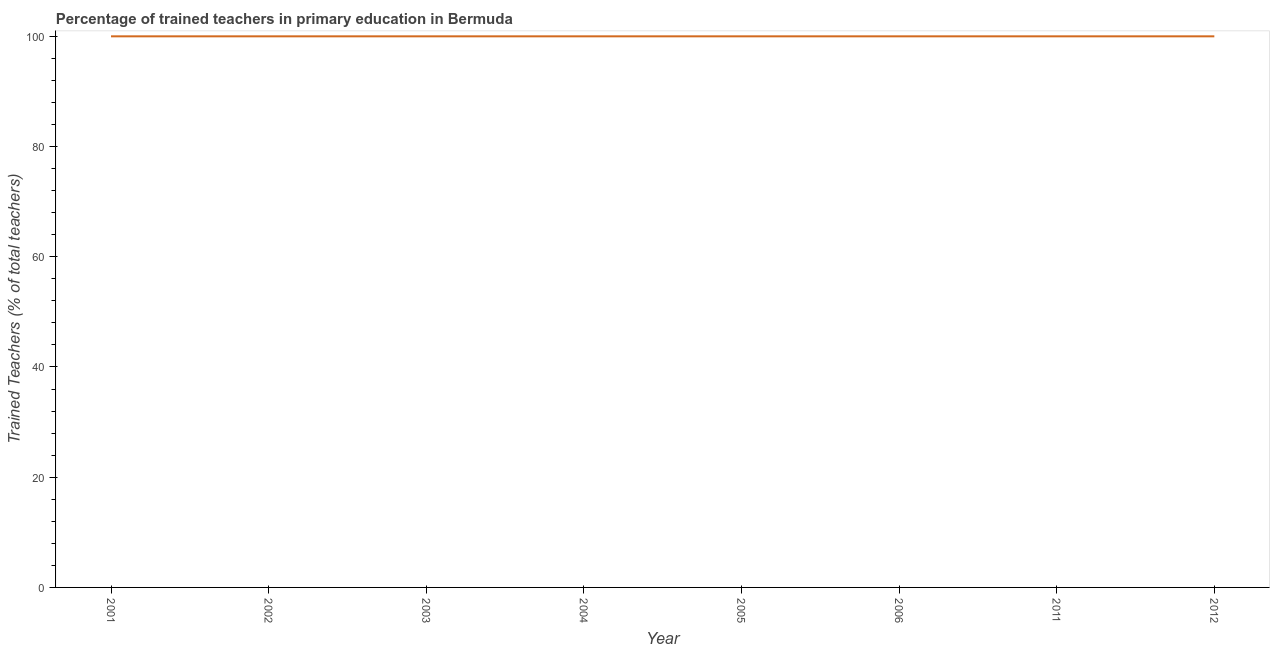In which year was the percentage of trained teachers minimum?
Provide a succinct answer. 2001. What is the sum of the percentage of trained teachers?
Offer a terse response. 800. What is the difference between the percentage of trained teachers in 2001 and 2005?
Give a very brief answer. 0. What is the average percentage of trained teachers per year?
Give a very brief answer. 100. What is the median percentage of trained teachers?
Provide a succinct answer. 100. In how many years, is the percentage of trained teachers greater than 16 %?
Offer a terse response. 8. Is the difference between the percentage of trained teachers in 2001 and 2004 greater than the difference between any two years?
Offer a very short reply. Yes. What is the difference between the highest and the second highest percentage of trained teachers?
Keep it short and to the point. 0. Is the sum of the percentage of trained teachers in 2003 and 2011 greater than the maximum percentage of trained teachers across all years?
Provide a short and direct response. Yes. What is the difference between the highest and the lowest percentage of trained teachers?
Make the answer very short. 0. In how many years, is the percentage of trained teachers greater than the average percentage of trained teachers taken over all years?
Ensure brevity in your answer.  0. Does the percentage of trained teachers monotonically increase over the years?
Your answer should be compact. No. How many lines are there?
Your answer should be compact. 1. What is the difference between two consecutive major ticks on the Y-axis?
Your answer should be very brief. 20. Are the values on the major ticks of Y-axis written in scientific E-notation?
Make the answer very short. No. Does the graph contain grids?
Keep it short and to the point. No. What is the title of the graph?
Give a very brief answer. Percentage of trained teachers in primary education in Bermuda. What is the label or title of the X-axis?
Offer a very short reply. Year. What is the label or title of the Y-axis?
Your answer should be very brief. Trained Teachers (% of total teachers). What is the Trained Teachers (% of total teachers) of 2004?
Provide a short and direct response. 100. What is the Trained Teachers (% of total teachers) in 2005?
Ensure brevity in your answer.  100. What is the Trained Teachers (% of total teachers) of 2011?
Make the answer very short. 100. What is the Trained Teachers (% of total teachers) of 2012?
Ensure brevity in your answer.  100. What is the difference between the Trained Teachers (% of total teachers) in 2001 and 2002?
Keep it short and to the point. 0. What is the difference between the Trained Teachers (% of total teachers) in 2001 and 2003?
Your answer should be compact. 0. What is the difference between the Trained Teachers (% of total teachers) in 2001 and 2012?
Offer a very short reply. 0. What is the difference between the Trained Teachers (% of total teachers) in 2002 and 2005?
Ensure brevity in your answer.  0. What is the difference between the Trained Teachers (% of total teachers) in 2002 and 2006?
Your answer should be very brief. 0. What is the difference between the Trained Teachers (% of total teachers) in 2002 and 2011?
Keep it short and to the point. 0. What is the difference between the Trained Teachers (% of total teachers) in 2003 and 2004?
Ensure brevity in your answer.  0. What is the difference between the Trained Teachers (% of total teachers) in 2003 and 2005?
Keep it short and to the point. 0. What is the difference between the Trained Teachers (% of total teachers) in 2003 and 2011?
Keep it short and to the point. 0. What is the difference between the Trained Teachers (% of total teachers) in 2003 and 2012?
Provide a succinct answer. 0. What is the difference between the Trained Teachers (% of total teachers) in 2004 and 2006?
Ensure brevity in your answer.  0. What is the difference between the Trained Teachers (% of total teachers) in 2004 and 2012?
Make the answer very short. 0. What is the difference between the Trained Teachers (% of total teachers) in 2005 and 2006?
Offer a very short reply. 0. What is the difference between the Trained Teachers (% of total teachers) in 2005 and 2011?
Make the answer very short. 0. What is the difference between the Trained Teachers (% of total teachers) in 2006 and 2012?
Provide a short and direct response. 0. What is the ratio of the Trained Teachers (% of total teachers) in 2001 to that in 2002?
Provide a short and direct response. 1. What is the ratio of the Trained Teachers (% of total teachers) in 2001 to that in 2004?
Your response must be concise. 1. What is the ratio of the Trained Teachers (% of total teachers) in 2001 to that in 2005?
Make the answer very short. 1. What is the ratio of the Trained Teachers (% of total teachers) in 2001 to that in 2012?
Ensure brevity in your answer.  1. What is the ratio of the Trained Teachers (% of total teachers) in 2002 to that in 2003?
Offer a terse response. 1. What is the ratio of the Trained Teachers (% of total teachers) in 2002 to that in 2004?
Provide a short and direct response. 1. What is the ratio of the Trained Teachers (% of total teachers) in 2002 to that in 2011?
Your answer should be very brief. 1. What is the ratio of the Trained Teachers (% of total teachers) in 2003 to that in 2006?
Provide a succinct answer. 1. What is the ratio of the Trained Teachers (% of total teachers) in 2004 to that in 2005?
Give a very brief answer. 1. What is the ratio of the Trained Teachers (% of total teachers) in 2004 to that in 2011?
Make the answer very short. 1. What is the ratio of the Trained Teachers (% of total teachers) in 2005 to that in 2011?
Offer a terse response. 1. What is the ratio of the Trained Teachers (% of total teachers) in 2005 to that in 2012?
Give a very brief answer. 1. What is the ratio of the Trained Teachers (% of total teachers) in 2006 to that in 2011?
Offer a very short reply. 1. What is the ratio of the Trained Teachers (% of total teachers) in 2006 to that in 2012?
Offer a terse response. 1. What is the ratio of the Trained Teachers (% of total teachers) in 2011 to that in 2012?
Make the answer very short. 1. 